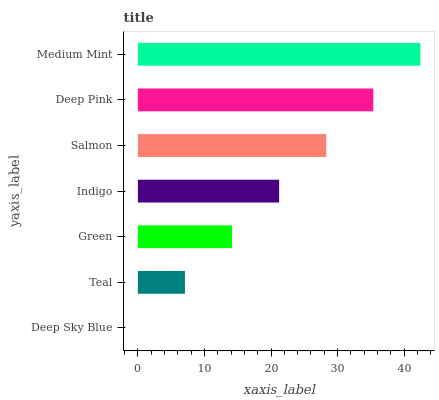Is Deep Sky Blue the minimum?
Answer yes or no. Yes. Is Medium Mint the maximum?
Answer yes or no. Yes. Is Teal the minimum?
Answer yes or no. No. Is Teal the maximum?
Answer yes or no. No. Is Teal greater than Deep Sky Blue?
Answer yes or no. Yes. Is Deep Sky Blue less than Teal?
Answer yes or no. Yes. Is Deep Sky Blue greater than Teal?
Answer yes or no. No. Is Teal less than Deep Sky Blue?
Answer yes or no. No. Is Indigo the high median?
Answer yes or no. Yes. Is Indigo the low median?
Answer yes or no. Yes. Is Green the high median?
Answer yes or no. No. Is Green the low median?
Answer yes or no. No. 